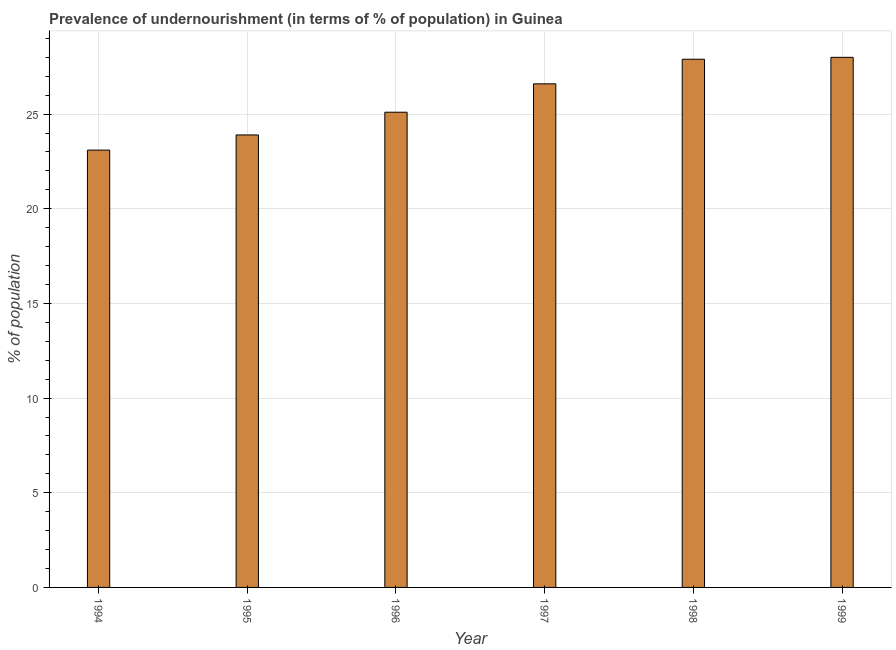Does the graph contain any zero values?
Provide a short and direct response. No. Does the graph contain grids?
Provide a short and direct response. Yes. What is the title of the graph?
Your response must be concise. Prevalence of undernourishment (in terms of % of population) in Guinea. What is the label or title of the X-axis?
Offer a terse response. Year. What is the label or title of the Y-axis?
Provide a succinct answer. % of population. What is the percentage of undernourished population in 1994?
Provide a short and direct response. 23.1. Across all years, what is the minimum percentage of undernourished population?
Provide a succinct answer. 23.1. In which year was the percentage of undernourished population maximum?
Offer a very short reply. 1999. What is the sum of the percentage of undernourished population?
Ensure brevity in your answer.  154.6. What is the difference between the percentage of undernourished population in 1994 and 1998?
Keep it short and to the point. -4.8. What is the average percentage of undernourished population per year?
Your answer should be very brief. 25.77. What is the median percentage of undernourished population?
Provide a short and direct response. 25.85. In how many years, is the percentage of undernourished population greater than 18 %?
Your response must be concise. 6. What is the ratio of the percentage of undernourished population in 1995 to that in 1997?
Offer a terse response. 0.9. Is the difference between the percentage of undernourished population in 1995 and 1998 greater than the difference between any two years?
Provide a short and direct response. No. What is the difference between the highest and the second highest percentage of undernourished population?
Provide a short and direct response. 0.1. Is the sum of the percentage of undernourished population in 1995 and 1996 greater than the maximum percentage of undernourished population across all years?
Ensure brevity in your answer.  Yes. In how many years, is the percentage of undernourished population greater than the average percentage of undernourished population taken over all years?
Provide a short and direct response. 3. How many bars are there?
Provide a short and direct response. 6. Are all the bars in the graph horizontal?
Give a very brief answer. No. Are the values on the major ticks of Y-axis written in scientific E-notation?
Provide a short and direct response. No. What is the % of population in 1994?
Offer a terse response. 23.1. What is the % of population in 1995?
Your answer should be very brief. 23.9. What is the % of population of 1996?
Your response must be concise. 25.1. What is the % of population in 1997?
Ensure brevity in your answer.  26.6. What is the % of population in 1998?
Ensure brevity in your answer.  27.9. What is the % of population of 1999?
Offer a terse response. 28. What is the difference between the % of population in 1994 and 1995?
Make the answer very short. -0.8. What is the difference between the % of population in 1994 and 1996?
Make the answer very short. -2. What is the difference between the % of population in 1995 and 1998?
Your answer should be very brief. -4. What is the difference between the % of population in 1996 and 1999?
Your response must be concise. -2.9. What is the difference between the % of population in 1997 and 1999?
Provide a short and direct response. -1.4. What is the ratio of the % of population in 1994 to that in 1995?
Ensure brevity in your answer.  0.97. What is the ratio of the % of population in 1994 to that in 1997?
Provide a succinct answer. 0.87. What is the ratio of the % of population in 1994 to that in 1998?
Your answer should be compact. 0.83. What is the ratio of the % of population in 1994 to that in 1999?
Offer a terse response. 0.82. What is the ratio of the % of population in 1995 to that in 1996?
Your answer should be compact. 0.95. What is the ratio of the % of population in 1995 to that in 1997?
Your response must be concise. 0.9. What is the ratio of the % of population in 1995 to that in 1998?
Keep it short and to the point. 0.86. What is the ratio of the % of population in 1995 to that in 1999?
Provide a succinct answer. 0.85. What is the ratio of the % of population in 1996 to that in 1997?
Give a very brief answer. 0.94. What is the ratio of the % of population in 1996 to that in 1998?
Your answer should be very brief. 0.9. What is the ratio of the % of population in 1996 to that in 1999?
Your answer should be compact. 0.9. What is the ratio of the % of population in 1997 to that in 1998?
Ensure brevity in your answer.  0.95. What is the ratio of the % of population in 1998 to that in 1999?
Give a very brief answer. 1. 